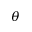Convert formula to latex. <formula><loc_0><loc_0><loc_500><loc_500>\theta</formula> 